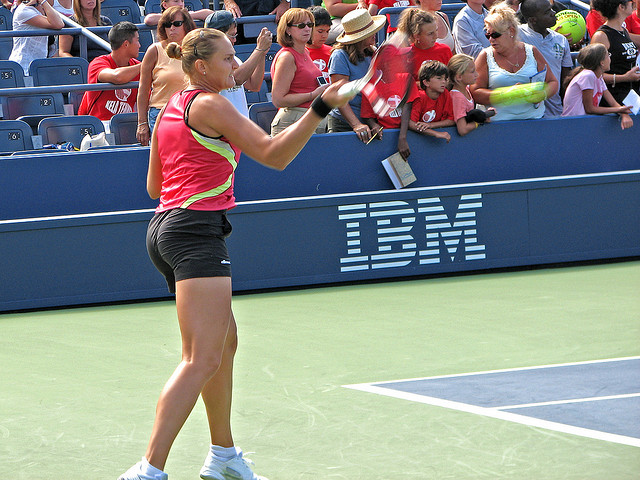Read all the text in this image. IBM P 5 1 S 